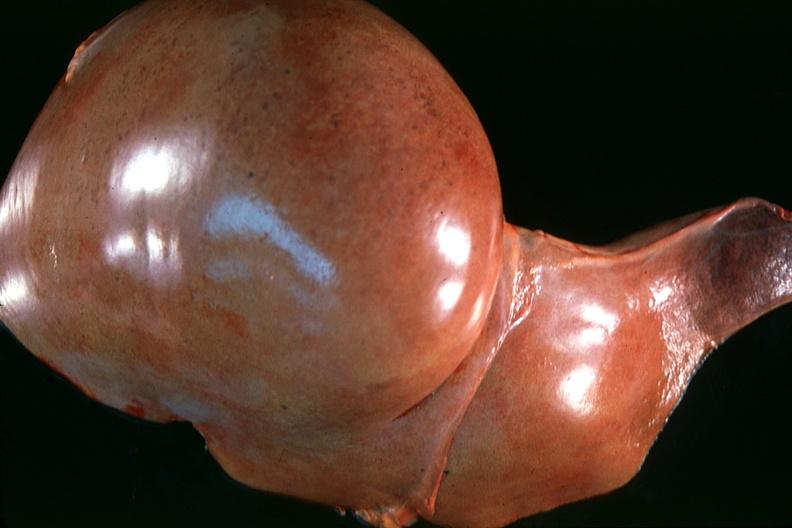what does this image show?
Answer the question using a single word or phrase. Normal liver 